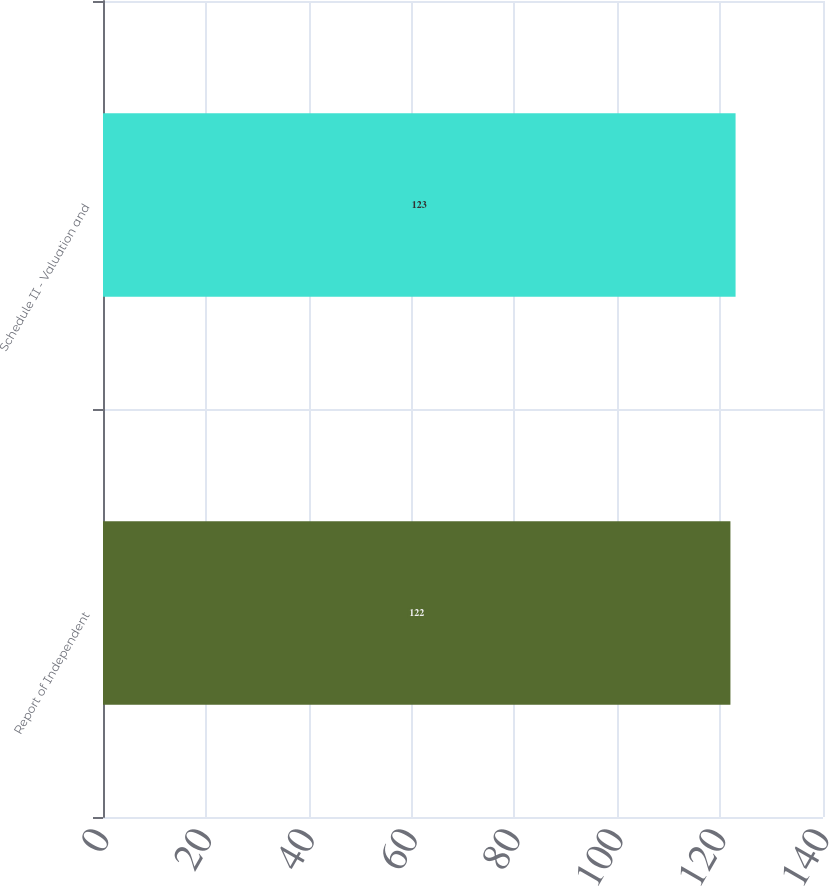Convert chart to OTSL. <chart><loc_0><loc_0><loc_500><loc_500><bar_chart><fcel>Report of Independent<fcel>Schedule II - Valuation and<nl><fcel>122<fcel>123<nl></chart> 